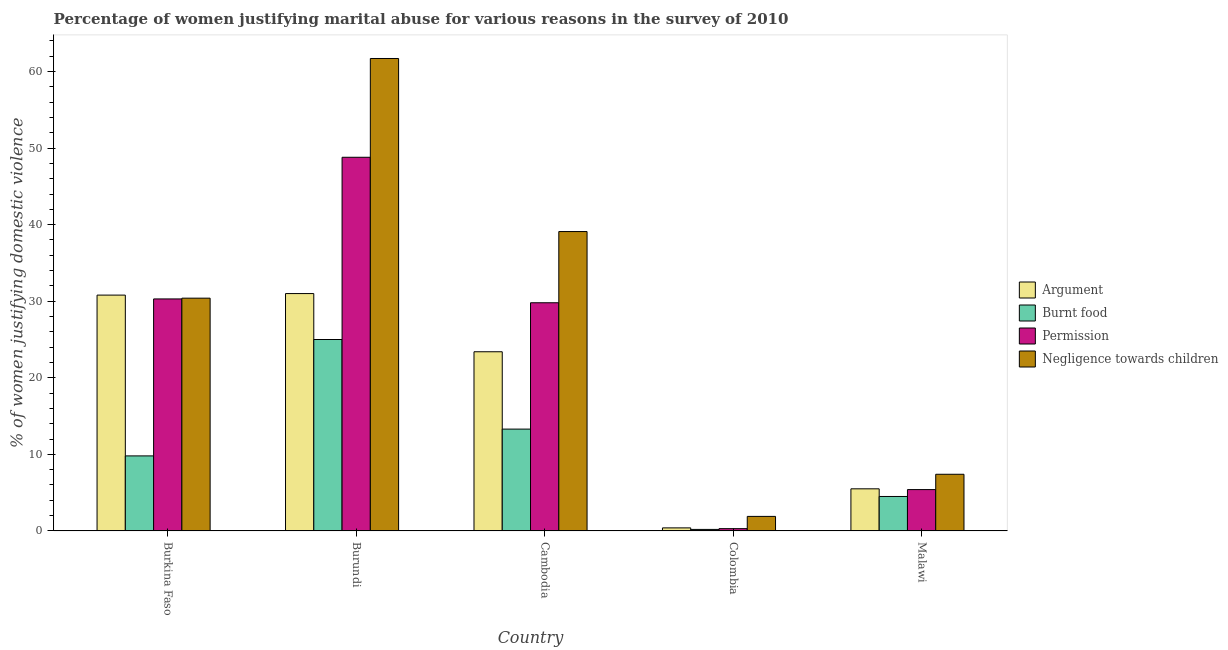How many different coloured bars are there?
Your answer should be very brief. 4. How many groups of bars are there?
Provide a short and direct response. 5. Are the number of bars on each tick of the X-axis equal?
Offer a terse response. Yes. How many bars are there on the 3rd tick from the left?
Provide a succinct answer. 4. How many bars are there on the 4th tick from the right?
Ensure brevity in your answer.  4. What is the label of the 2nd group of bars from the left?
Ensure brevity in your answer.  Burundi. In how many cases, is the number of bars for a given country not equal to the number of legend labels?
Offer a terse response. 0. What is the percentage of women justifying abuse for going without permission in Burundi?
Offer a very short reply. 48.8. Across all countries, what is the maximum percentage of women justifying abuse for showing negligence towards children?
Give a very brief answer. 61.7. Across all countries, what is the minimum percentage of women justifying abuse for showing negligence towards children?
Provide a short and direct response. 1.9. In which country was the percentage of women justifying abuse for showing negligence towards children maximum?
Keep it short and to the point. Burundi. What is the total percentage of women justifying abuse for going without permission in the graph?
Your answer should be compact. 114.6. What is the difference between the percentage of women justifying abuse in the case of an argument in Cambodia and the percentage of women justifying abuse for going without permission in Malawi?
Your answer should be very brief. 18. What is the average percentage of women justifying abuse in the case of an argument per country?
Your response must be concise. 18.22. In how many countries, is the percentage of women justifying abuse for burning food greater than 14 %?
Provide a short and direct response. 1. What is the ratio of the percentage of women justifying abuse in the case of an argument in Burkina Faso to that in Colombia?
Keep it short and to the point. 77. What is the difference between the highest and the second highest percentage of women justifying abuse in the case of an argument?
Offer a terse response. 0.2. What is the difference between the highest and the lowest percentage of women justifying abuse for going without permission?
Provide a short and direct response. 48.5. Is the sum of the percentage of women justifying abuse for going without permission in Burkina Faso and Burundi greater than the maximum percentage of women justifying abuse in the case of an argument across all countries?
Offer a terse response. Yes. What does the 2nd bar from the left in Burkina Faso represents?
Give a very brief answer. Burnt food. What does the 3rd bar from the right in Burkina Faso represents?
Offer a terse response. Burnt food. Is it the case that in every country, the sum of the percentage of women justifying abuse in the case of an argument and percentage of women justifying abuse for burning food is greater than the percentage of women justifying abuse for going without permission?
Your answer should be very brief. Yes. Are the values on the major ticks of Y-axis written in scientific E-notation?
Provide a short and direct response. No. Does the graph contain any zero values?
Make the answer very short. No. Where does the legend appear in the graph?
Provide a succinct answer. Center right. How many legend labels are there?
Make the answer very short. 4. What is the title of the graph?
Your answer should be very brief. Percentage of women justifying marital abuse for various reasons in the survey of 2010. What is the label or title of the X-axis?
Ensure brevity in your answer.  Country. What is the label or title of the Y-axis?
Your answer should be very brief. % of women justifying domestic violence. What is the % of women justifying domestic violence of Argument in Burkina Faso?
Your answer should be very brief. 30.8. What is the % of women justifying domestic violence in Burnt food in Burkina Faso?
Offer a very short reply. 9.8. What is the % of women justifying domestic violence in Permission in Burkina Faso?
Offer a terse response. 30.3. What is the % of women justifying domestic violence of Negligence towards children in Burkina Faso?
Keep it short and to the point. 30.4. What is the % of women justifying domestic violence in Argument in Burundi?
Keep it short and to the point. 31. What is the % of women justifying domestic violence of Permission in Burundi?
Make the answer very short. 48.8. What is the % of women justifying domestic violence in Negligence towards children in Burundi?
Offer a very short reply. 61.7. What is the % of women justifying domestic violence of Argument in Cambodia?
Give a very brief answer. 23.4. What is the % of women justifying domestic violence in Burnt food in Cambodia?
Give a very brief answer. 13.3. What is the % of women justifying domestic violence of Permission in Cambodia?
Ensure brevity in your answer.  29.8. What is the % of women justifying domestic violence in Negligence towards children in Cambodia?
Give a very brief answer. 39.1. What is the % of women justifying domestic violence in Burnt food in Colombia?
Your answer should be compact. 0.2. What is the % of women justifying domestic violence in Argument in Malawi?
Make the answer very short. 5.5. What is the % of women justifying domestic violence of Burnt food in Malawi?
Provide a succinct answer. 4.5. Across all countries, what is the maximum % of women justifying domestic violence in Argument?
Your answer should be very brief. 31. Across all countries, what is the maximum % of women justifying domestic violence in Burnt food?
Provide a short and direct response. 25. Across all countries, what is the maximum % of women justifying domestic violence in Permission?
Offer a terse response. 48.8. Across all countries, what is the maximum % of women justifying domestic violence of Negligence towards children?
Offer a terse response. 61.7. Across all countries, what is the minimum % of women justifying domestic violence of Permission?
Your answer should be compact. 0.3. Across all countries, what is the minimum % of women justifying domestic violence in Negligence towards children?
Provide a succinct answer. 1.9. What is the total % of women justifying domestic violence of Argument in the graph?
Provide a succinct answer. 91.1. What is the total % of women justifying domestic violence in Burnt food in the graph?
Give a very brief answer. 52.8. What is the total % of women justifying domestic violence in Permission in the graph?
Keep it short and to the point. 114.6. What is the total % of women justifying domestic violence of Negligence towards children in the graph?
Provide a succinct answer. 140.5. What is the difference between the % of women justifying domestic violence of Argument in Burkina Faso and that in Burundi?
Offer a terse response. -0.2. What is the difference between the % of women justifying domestic violence of Burnt food in Burkina Faso and that in Burundi?
Provide a short and direct response. -15.2. What is the difference between the % of women justifying domestic violence in Permission in Burkina Faso and that in Burundi?
Your answer should be very brief. -18.5. What is the difference between the % of women justifying domestic violence in Negligence towards children in Burkina Faso and that in Burundi?
Your response must be concise. -31.3. What is the difference between the % of women justifying domestic violence in Negligence towards children in Burkina Faso and that in Cambodia?
Offer a terse response. -8.7. What is the difference between the % of women justifying domestic violence in Argument in Burkina Faso and that in Colombia?
Offer a terse response. 30.4. What is the difference between the % of women justifying domestic violence of Permission in Burkina Faso and that in Colombia?
Offer a terse response. 30. What is the difference between the % of women justifying domestic violence in Argument in Burkina Faso and that in Malawi?
Ensure brevity in your answer.  25.3. What is the difference between the % of women justifying domestic violence in Permission in Burkina Faso and that in Malawi?
Provide a short and direct response. 24.9. What is the difference between the % of women justifying domestic violence in Argument in Burundi and that in Cambodia?
Provide a short and direct response. 7.6. What is the difference between the % of women justifying domestic violence in Negligence towards children in Burundi and that in Cambodia?
Make the answer very short. 22.6. What is the difference between the % of women justifying domestic violence in Argument in Burundi and that in Colombia?
Give a very brief answer. 30.6. What is the difference between the % of women justifying domestic violence of Burnt food in Burundi and that in Colombia?
Give a very brief answer. 24.8. What is the difference between the % of women justifying domestic violence of Permission in Burundi and that in Colombia?
Ensure brevity in your answer.  48.5. What is the difference between the % of women justifying domestic violence in Negligence towards children in Burundi and that in Colombia?
Offer a terse response. 59.8. What is the difference between the % of women justifying domestic violence in Burnt food in Burundi and that in Malawi?
Provide a succinct answer. 20.5. What is the difference between the % of women justifying domestic violence in Permission in Burundi and that in Malawi?
Your answer should be compact. 43.4. What is the difference between the % of women justifying domestic violence of Negligence towards children in Burundi and that in Malawi?
Make the answer very short. 54.3. What is the difference between the % of women justifying domestic violence in Burnt food in Cambodia and that in Colombia?
Give a very brief answer. 13.1. What is the difference between the % of women justifying domestic violence in Permission in Cambodia and that in Colombia?
Keep it short and to the point. 29.5. What is the difference between the % of women justifying domestic violence in Negligence towards children in Cambodia and that in Colombia?
Ensure brevity in your answer.  37.2. What is the difference between the % of women justifying domestic violence of Permission in Cambodia and that in Malawi?
Offer a very short reply. 24.4. What is the difference between the % of women justifying domestic violence in Negligence towards children in Cambodia and that in Malawi?
Ensure brevity in your answer.  31.7. What is the difference between the % of women justifying domestic violence of Argument in Colombia and that in Malawi?
Your response must be concise. -5.1. What is the difference between the % of women justifying domestic violence of Permission in Colombia and that in Malawi?
Ensure brevity in your answer.  -5.1. What is the difference between the % of women justifying domestic violence in Argument in Burkina Faso and the % of women justifying domestic violence in Permission in Burundi?
Give a very brief answer. -18. What is the difference between the % of women justifying domestic violence in Argument in Burkina Faso and the % of women justifying domestic violence in Negligence towards children in Burundi?
Give a very brief answer. -30.9. What is the difference between the % of women justifying domestic violence of Burnt food in Burkina Faso and the % of women justifying domestic violence of Permission in Burundi?
Your response must be concise. -39. What is the difference between the % of women justifying domestic violence in Burnt food in Burkina Faso and the % of women justifying domestic violence in Negligence towards children in Burundi?
Offer a terse response. -51.9. What is the difference between the % of women justifying domestic violence in Permission in Burkina Faso and the % of women justifying domestic violence in Negligence towards children in Burundi?
Your answer should be compact. -31.4. What is the difference between the % of women justifying domestic violence of Argument in Burkina Faso and the % of women justifying domestic violence of Burnt food in Cambodia?
Keep it short and to the point. 17.5. What is the difference between the % of women justifying domestic violence of Argument in Burkina Faso and the % of women justifying domestic violence of Permission in Cambodia?
Provide a succinct answer. 1. What is the difference between the % of women justifying domestic violence in Argument in Burkina Faso and the % of women justifying domestic violence in Negligence towards children in Cambodia?
Provide a succinct answer. -8.3. What is the difference between the % of women justifying domestic violence of Burnt food in Burkina Faso and the % of women justifying domestic violence of Negligence towards children in Cambodia?
Keep it short and to the point. -29.3. What is the difference between the % of women justifying domestic violence in Permission in Burkina Faso and the % of women justifying domestic violence in Negligence towards children in Cambodia?
Your answer should be compact. -8.8. What is the difference between the % of women justifying domestic violence in Argument in Burkina Faso and the % of women justifying domestic violence in Burnt food in Colombia?
Make the answer very short. 30.6. What is the difference between the % of women justifying domestic violence of Argument in Burkina Faso and the % of women justifying domestic violence of Permission in Colombia?
Provide a succinct answer. 30.5. What is the difference between the % of women justifying domestic violence of Argument in Burkina Faso and the % of women justifying domestic violence of Negligence towards children in Colombia?
Offer a terse response. 28.9. What is the difference between the % of women justifying domestic violence in Permission in Burkina Faso and the % of women justifying domestic violence in Negligence towards children in Colombia?
Offer a very short reply. 28.4. What is the difference between the % of women justifying domestic violence in Argument in Burkina Faso and the % of women justifying domestic violence in Burnt food in Malawi?
Offer a very short reply. 26.3. What is the difference between the % of women justifying domestic violence of Argument in Burkina Faso and the % of women justifying domestic violence of Permission in Malawi?
Provide a succinct answer. 25.4. What is the difference between the % of women justifying domestic violence of Argument in Burkina Faso and the % of women justifying domestic violence of Negligence towards children in Malawi?
Your answer should be compact. 23.4. What is the difference between the % of women justifying domestic violence in Burnt food in Burkina Faso and the % of women justifying domestic violence in Permission in Malawi?
Your answer should be very brief. 4.4. What is the difference between the % of women justifying domestic violence in Burnt food in Burkina Faso and the % of women justifying domestic violence in Negligence towards children in Malawi?
Make the answer very short. 2.4. What is the difference between the % of women justifying domestic violence of Permission in Burkina Faso and the % of women justifying domestic violence of Negligence towards children in Malawi?
Your answer should be compact. 22.9. What is the difference between the % of women justifying domestic violence of Burnt food in Burundi and the % of women justifying domestic violence of Negligence towards children in Cambodia?
Your answer should be compact. -14.1. What is the difference between the % of women justifying domestic violence of Permission in Burundi and the % of women justifying domestic violence of Negligence towards children in Cambodia?
Provide a short and direct response. 9.7. What is the difference between the % of women justifying domestic violence in Argument in Burundi and the % of women justifying domestic violence in Burnt food in Colombia?
Your answer should be very brief. 30.8. What is the difference between the % of women justifying domestic violence of Argument in Burundi and the % of women justifying domestic violence of Permission in Colombia?
Offer a very short reply. 30.7. What is the difference between the % of women justifying domestic violence in Argument in Burundi and the % of women justifying domestic violence in Negligence towards children in Colombia?
Provide a short and direct response. 29.1. What is the difference between the % of women justifying domestic violence in Burnt food in Burundi and the % of women justifying domestic violence in Permission in Colombia?
Provide a short and direct response. 24.7. What is the difference between the % of women justifying domestic violence in Burnt food in Burundi and the % of women justifying domestic violence in Negligence towards children in Colombia?
Your answer should be compact. 23.1. What is the difference between the % of women justifying domestic violence in Permission in Burundi and the % of women justifying domestic violence in Negligence towards children in Colombia?
Ensure brevity in your answer.  46.9. What is the difference between the % of women justifying domestic violence of Argument in Burundi and the % of women justifying domestic violence of Burnt food in Malawi?
Offer a terse response. 26.5. What is the difference between the % of women justifying domestic violence in Argument in Burundi and the % of women justifying domestic violence in Permission in Malawi?
Keep it short and to the point. 25.6. What is the difference between the % of women justifying domestic violence in Argument in Burundi and the % of women justifying domestic violence in Negligence towards children in Malawi?
Your answer should be compact. 23.6. What is the difference between the % of women justifying domestic violence of Burnt food in Burundi and the % of women justifying domestic violence of Permission in Malawi?
Offer a terse response. 19.6. What is the difference between the % of women justifying domestic violence of Burnt food in Burundi and the % of women justifying domestic violence of Negligence towards children in Malawi?
Provide a short and direct response. 17.6. What is the difference between the % of women justifying domestic violence in Permission in Burundi and the % of women justifying domestic violence in Negligence towards children in Malawi?
Ensure brevity in your answer.  41.4. What is the difference between the % of women justifying domestic violence in Argument in Cambodia and the % of women justifying domestic violence in Burnt food in Colombia?
Provide a short and direct response. 23.2. What is the difference between the % of women justifying domestic violence in Argument in Cambodia and the % of women justifying domestic violence in Permission in Colombia?
Make the answer very short. 23.1. What is the difference between the % of women justifying domestic violence in Argument in Cambodia and the % of women justifying domestic violence in Negligence towards children in Colombia?
Give a very brief answer. 21.5. What is the difference between the % of women justifying domestic violence in Burnt food in Cambodia and the % of women justifying domestic violence in Negligence towards children in Colombia?
Make the answer very short. 11.4. What is the difference between the % of women justifying domestic violence of Permission in Cambodia and the % of women justifying domestic violence of Negligence towards children in Colombia?
Ensure brevity in your answer.  27.9. What is the difference between the % of women justifying domestic violence of Argument in Cambodia and the % of women justifying domestic violence of Burnt food in Malawi?
Your response must be concise. 18.9. What is the difference between the % of women justifying domestic violence in Argument in Cambodia and the % of women justifying domestic violence in Permission in Malawi?
Give a very brief answer. 18. What is the difference between the % of women justifying domestic violence in Burnt food in Cambodia and the % of women justifying domestic violence in Permission in Malawi?
Keep it short and to the point. 7.9. What is the difference between the % of women justifying domestic violence in Permission in Cambodia and the % of women justifying domestic violence in Negligence towards children in Malawi?
Offer a very short reply. 22.4. What is the difference between the % of women justifying domestic violence of Burnt food in Colombia and the % of women justifying domestic violence of Negligence towards children in Malawi?
Offer a very short reply. -7.2. What is the average % of women justifying domestic violence in Argument per country?
Give a very brief answer. 18.22. What is the average % of women justifying domestic violence in Burnt food per country?
Ensure brevity in your answer.  10.56. What is the average % of women justifying domestic violence of Permission per country?
Your answer should be compact. 22.92. What is the average % of women justifying domestic violence of Negligence towards children per country?
Ensure brevity in your answer.  28.1. What is the difference between the % of women justifying domestic violence of Argument and % of women justifying domestic violence of Burnt food in Burkina Faso?
Keep it short and to the point. 21. What is the difference between the % of women justifying domestic violence of Argument and % of women justifying domestic violence of Permission in Burkina Faso?
Offer a very short reply. 0.5. What is the difference between the % of women justifying domestic violence of Burnt food and % of women justifying domestic violence of Permission in Burkina Faso?
Your response must be concise. -20.5. What is the difference between the % of women justifying domestic violence of Burnt food and % of women justifying domestic violence of Negligence towards children in Burkina Faso?
Offer a very short reply. -20.6. What is the difference between the % of women justifying domestic violence of Permission and % of women justifying domestic violence of Negligence towards children in Burkina Faso?
Offer a terse response. -0.1. What is the difference between the % of women justifying domestic violence in Argument and % of women justifying domestic violence in Permission in Burundi?
Make the answer very short. -17.8. What is the difference between the % of women justifying domestic violence in Argument and % of women justifying domestic violence in Negligence towards children in Burundi?
Keep it short and to the point. -30.7. What is the difference between the % of women justifying domestic violence in Burnt food and % of women justifying domestic violence in Permission in Burundi?
Ensure brevity in your answer.  -23.8. What is the difference between the % of women justifying domestic violence of Burnt food and % of women justifying domestic violence of Negligence towards children in Burundi?
Offer a very short reply. -36.7. What is the difference between the % of women justifying domestic violence in Argument and % of women justifying domestic violence in Burnt food in Cambodia?
Your response must be concise. 10.1. What is the difference between the % of women justifying domestic violence in Argument and % of women justifying domestic violence in Permission in Cambodia?
Provide a short and direct response. -6.4. What is the difference between the % of women justifying domestic violence in Argument and % of women justifying domestic violence in Negligence towards children in Cambodia?
Your response must be concise. -15.7. What is the difference between the % of women justifying domestic violence in Burnt food and % of women justifying domestic violence in Permission in Cambodia?
Offer a terse response. -16.5. What is the difference between the % of women justifying domestic violence of Burnt food and % of women justifying domestic violence of Negligence towards children in Cambodia?
Your answer should be compact. -25.8. What is the difference between the % of women justifying domestic violence of Argument and % of women justifying domestic violence of Negligence towards children in Colombia?
Offer a very short reply. -1.5. What is the difference between the % of women justifying domestic violence in Burnt food and % of women justifying domestic violence in Negligence towards children in Colombia?
Your answer should be very brief. -1.7. What is the difference between the % of women justifying domestic violence in Argument and % of women justifying domestic violence in Burnt food in Malawi?
Give a very brief answer. 1. What is the difference between the % of women justifying domestic violence in Argument and % of women justifying domestic violence in Permission in Malawi?
Keep it short and to the point. 0.1. What is the difference between the % of women justifying domestic violence in Burnt food and % of women justifying domestic violence in Permission in Malawi?
Your answer should be compact. -0.9. What is the difference between the % of women justifying domestic violence of Burnt food and % of women justifying domestic violence of Negligence towards children in Malawi?
Offer a terse response. -2.9. What is the ratio of the % of women justifying domestic violence in Burnt food in Burkina Faso to that in Burundi?
Offer a terse response. 0.39. What is the ratio of the % of women justifying domestic violence of Permission in Burkina Faso to that in Burundi?
Your answer should be very brief. 0.62. What is the ratio of the % of women justifying domestic violence of Negligence towards children in Burkina Faso to that in Burundi?
Your answer should be compact. 0.49. What is the ratio of the % of women justifying domestic violence in Argument in Burkina Faso to that in Cambodia?
Keep it short and to the point. 1.32. What is the ratio of the % of women justifying domestic violence of Burnt food in Burkina Faso to that in Cambodia?
Provide a succinct answer. 0.74. What is the ratio of the % of women justifying domestic violence of Permission in Burkina Faso to that in Cambodia?
Give a very brief answer. 1.02. What is the ratio of the % of women justifying domestic violence of Negligence towards children in Burkina Faso to that in Cambodia?
Offer a very short reply. 0.78. What is the ratio of the % of women justifying domestic violence in Burnt food in Burkina Faso to that in Colombia?
Offer a very short reply. 49. What is the ratio of the % of women justifying domestic violence in Permission in Burkina Faso to that in Colombia?
Your answer should be compact. 101. What is the ratio of the % of women justifying domestic violence of Negligence towards children in Burkina Faso to that in Colombia?
Your answer should be compact. 16. What is the ratio of the % of women justifying domestic violence of Argument in Burkina Faso to that in Malawi?
Provide a short and direct response. 5.6. What is the ratio of the % of women justifying domestic violence of Burnt food in Burkina Faso to that in Malawi?
Your answer should be compact. 2.18. What is the ratio of the % of women justifying domestic violence of Permission in Burkina Faso to that in Malawi?
Give a very brief answer. 5.61. What is the ratio of the % of women justifying domestic violence of Negligence towards children in Burkina Faso to that in Malawi?
Give a very brief answer. 4.11. What is the ratio of the % of women justifying domestic violence in Argument in Burundi to that in Cambodia?
Give a very brief answer. 1.32. What is the ratio of the % of women justifying domestic violence of Burnt food in Burundi to that in Cambodia?
Give a very brief answer. 1.88. What is the ratio of the % of women justifying domestic violence in Permission in Burundi to that in Cambodia?
Ensure brevity in your answer.  1.64. What is the ratio of the % of women justifying domestic violence of Negligence towards children in Burundi to that in Cambodia?
Make the answer very short. 1.58. What is the ratio of the % of women justifying domestic violence of Argument in Burundi to that in Colombia?
Keep it short and to the point. 77.5. What is the ratio of the % of women justifying domestic violence in Burnt food in Burundi to that in Colombia?
Your answer should be compact. 125. What is the ratio of the % of women justifying domestic violence in Permission in Burundi to that in Colombia?
Provide a short and direct response. 162.67. What is the ratio of the % of women justifying domestic violence of Negligence towards children in Burundi to that in Colombia?
Ensure brevity in your answer.  32.47. What is the ratio of the % of women justifying domestic violence of Argument in Burundi to that in Malawi?
Provide a short and direct response. 5.64. What is the ratio of the % of women justifying domestic violence of Burnt food in Burundi to that in Malawi?
Your answer should be compact. 5.56. What is the ratio of the % of women justifying domestic violence in Permission in Burundi to that in Malawi?
Make the answer very short. 9.04. What is the ratio of the % of women justifying domestic violence of Negligence towards children in Burundi to that in Malawi?
Provide a short and direct response. 8.34. What is the ratio of the % of women justifying domestic violence of Argument in Cambodia to that in Colombia?
Your response must be concise. 58.5. What is the ratio of the % of women justifying domestic violence of Burnt food in Cambodia to that in Colombia?
Keep it short and to the point. 66.5. What is the ratio of the % of women justifying domestic violence in Permission in Cambodia to that in Colombia?
Offer a very short reply. 99.33. What is the ratio of the % of women justifying domestic violence of Negligence towards children in Cambodia to that in Colombia?
Your answer should be very brief. 20.58. What is the ratio of the % of women justifying domestic violence in Argument in Cambodia to that in Malawi?
Provide a short and direct response. 4.25. What is the ratio of the % of women justifying domestic violence of Burnt food in Cambodia to that in Malawi?
Offer a terse response. 2.96. What is the ratio of the % of women justifying domestic violence of Permission in Cambodia to that in Malawi?
Your answer should be very brief. 5.52. What is the ratio of the % of women justifying domestic violence of Negligence towards children in Cambodia to that in Malawi?
Provide a succinct answer. 5.28. What is the ratio of the % of women justifying domestic violence of Argument in Colombia to that in Malawi?
Provide a short and direct response. 0.07. What is the ratio of the % of women justifying domestic violence in Burnt food in Colombia to that in Malawi?
Your response must be concise. 0.04. What is the ratio of the % of women justifying domestic violence of Permission in Colombia to that in Malawi?
Provide a succinct answer. 0.06. What is the ratio of the % of women justifying domestic violence in Negligence towards children in Colombia to that in Malawi?
Your response must be concise. 0.26. What is the difference between the highest and the second highest % of women justifying domestic violence in Burnt food?
Make the answer very short. 11.7. What is the difference between the highest and the second highest % of women justifying domestic violence of Negligence towards children?
Your answer should be very brief. 22.6. What is the difference between the highest and the lowest % of women justifying domestic violence of Argument?
Your answer should be compact. 30.6. What is the difference between the highest and the lowest % of women justifying domestic violence of Burnt food?
Offer a very short reply. 24.8. What is the difference between the highest and the lowest % of women justifying domestic violence of Permission?
Your response must be concise. 48.5. What is the difference between the highest and the lowest % of women justifying domestic violence in Negligence towards children?
Offer a terse response. 59.8. 